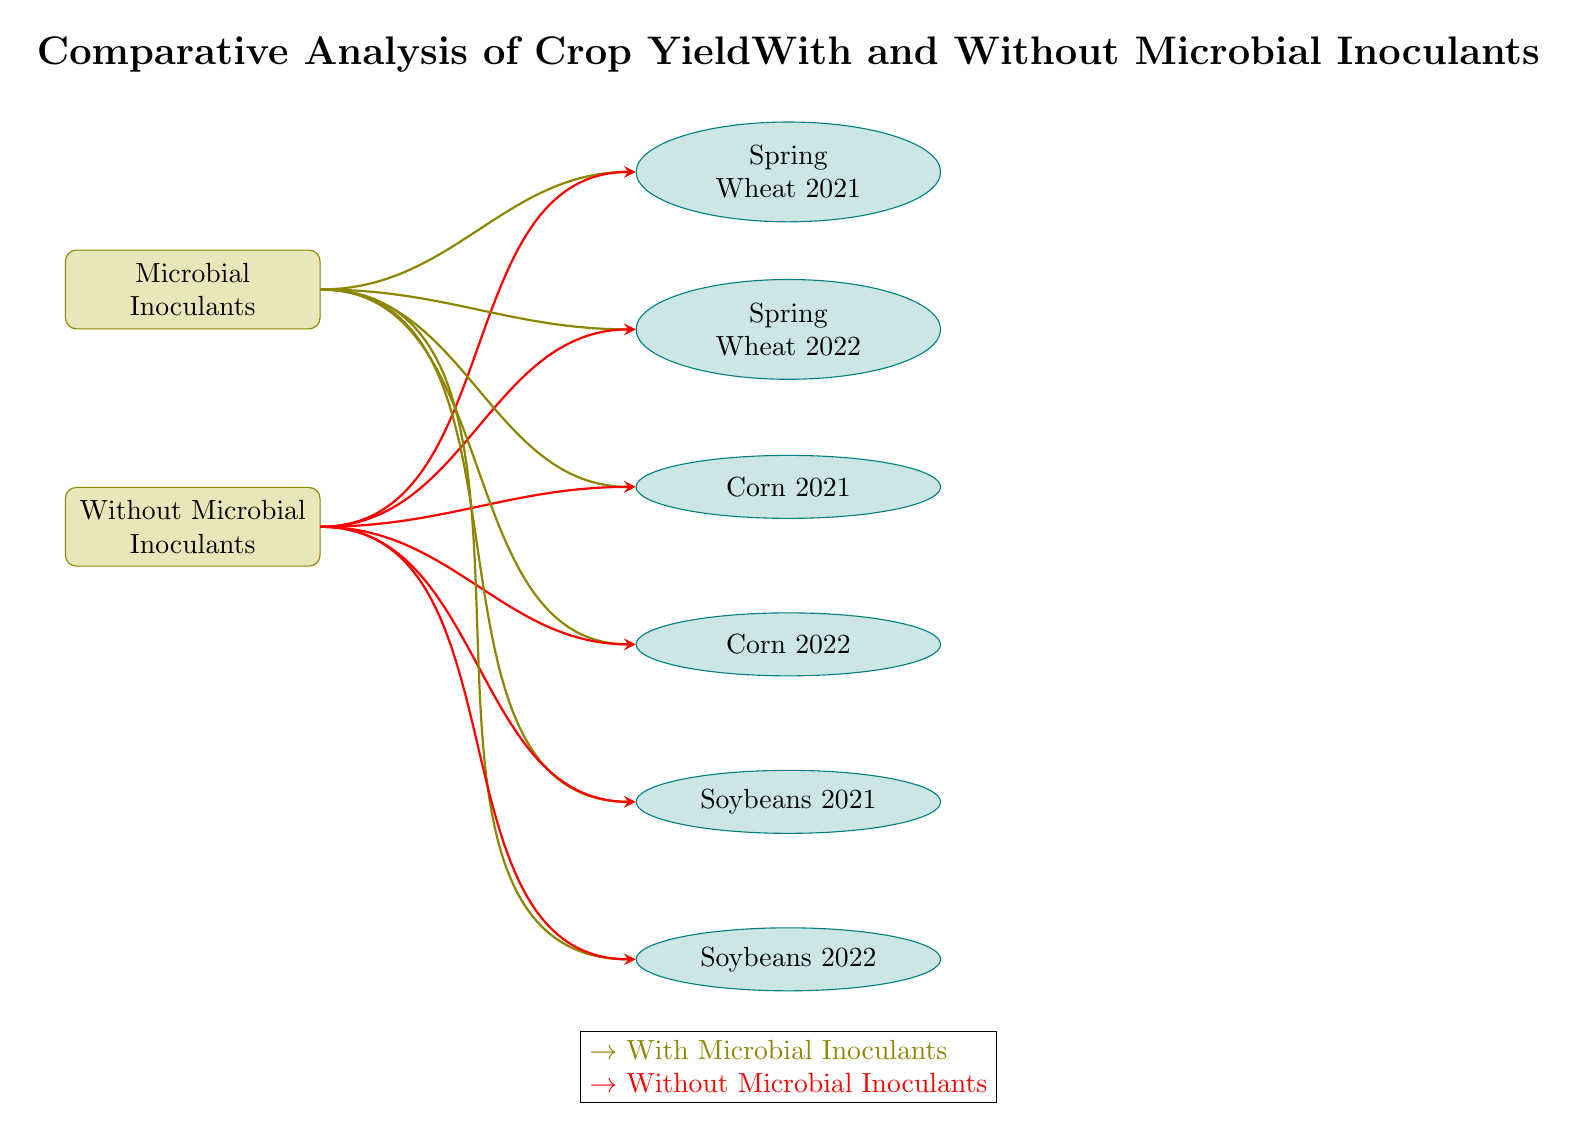What are the two treatment categories depicted in the diagram? The diagram shows two treatment categories: "Microbial Inoculants" and "Without Microbial Inoculants." These are represented as treatment nodes in the diagram, indicating the conditions being compared for crop yield analysis.
Answer: Microbial Inoculants, Without Microbial Inoculants How many crops are represented in the diagram? The diagram depicts six crops: Spring Wheat 2021, Spring Wheat 2022, Corn 2021, Corn 2022, Soybeans 2021, and Soybeans 2022. Each crop is represented as an ellipse node connected to both treatment categories.
Answer: 6 Which crop is shown in the second position from the top? The second crop from the top in the diagram is "Spring Wheat 2022," positioned just below "Spring Wheat 2021." This is determined by counting the vertical placement of the crop nodes.
Answer: Spring Wheat 2022 What do the arrows represent in the diagram? The arrows in the diagram represent the relationship between the treatment categories and the crop yields. Different colored arrows indicate yields with or without microbial inoculants. Specifically, olive arrows indicate yields with microbial inoculants, while red arrows represent yields without microbial inoculants.
Answer: Relationship between treatments and yields If a crop is represented with an olive arrow, what can be inferred about its treatment? A crop connected with an olive arrow is being evaluated for its yield with microbial inoculants. The color coding of the arrows indicates the specific treatment conditions for each crop in the analysis.
Answer: With Microbial Inoculants Which crop pair consists of the same type of plant grown in consecutive years? The crop pair "Corn 2021" and "Corn 2022" consists of the same type of plant, corn, cultivated in consecutive years. They are both positioned at the same vertical level, indicating that they share the same category but different growing seasons.
Answer: Corn 2021, Corn 2022 Which color represents yields without microbial inoculants? The color red represents yields without microbial inoculants in the diagram, as indicated by the red arrows pointing to the respective crop nodes.
Answer: Red From which treatment does "Soybeans 2022" receive its connection? "Soybeans 2022" receives connections from both treatment categories: "Microbial Inoculants" via an olive arrow and "Without Microbial Inoculants" via a red arrow, indicating the comparative analysis for this specific crop.
Answer: Both treatments 